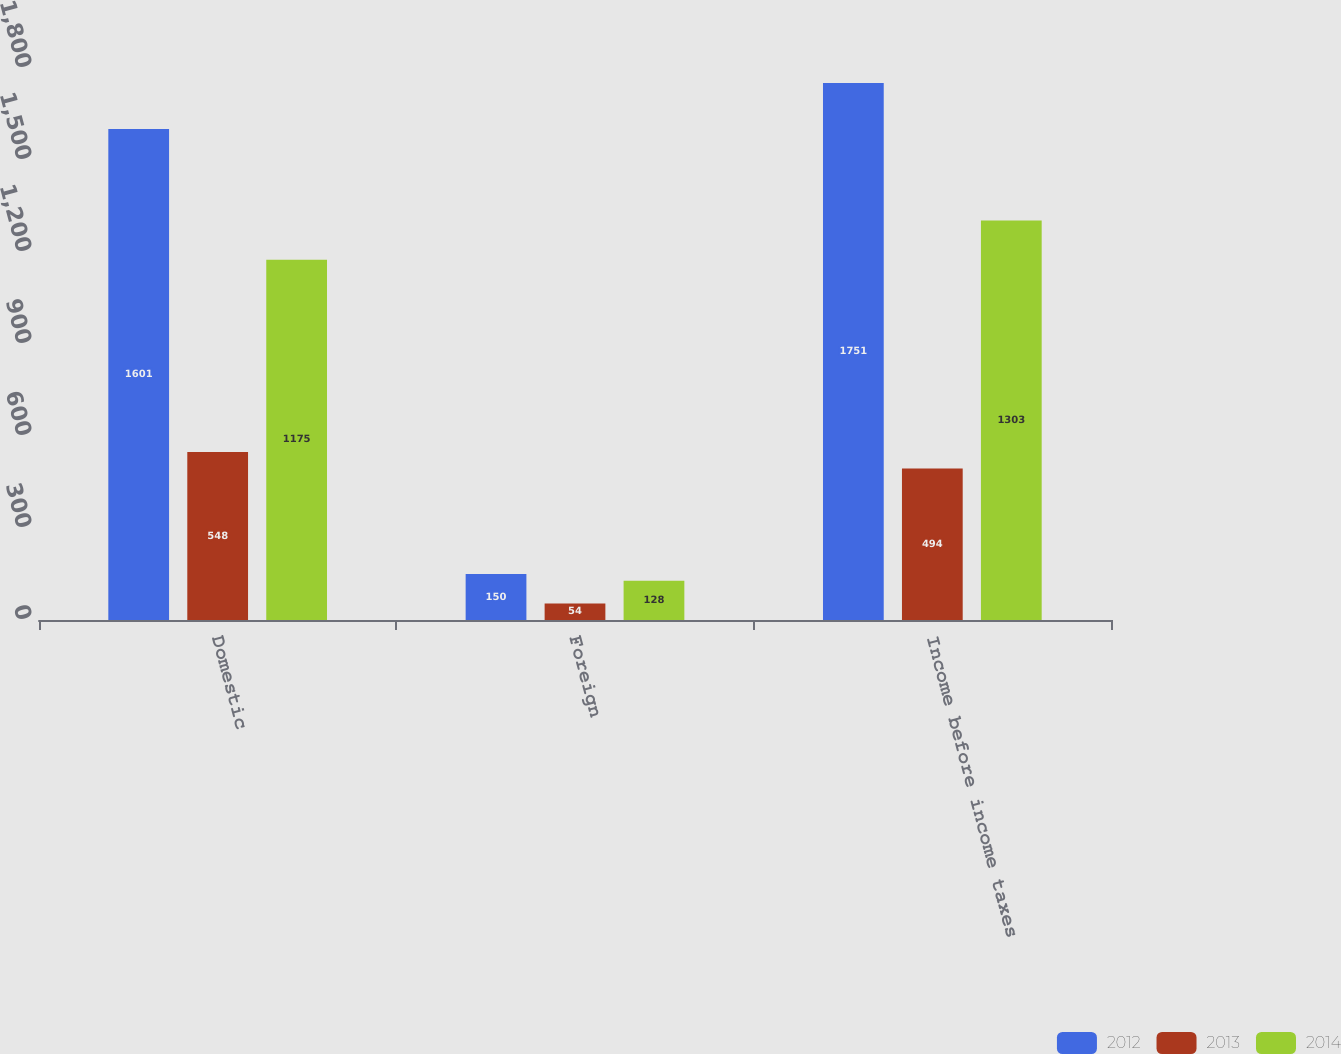Convert chart to OTSL. <chart><loc_0><loc_0><loc_500><loc_500><stacked_bar_chart><ecel><fcel>Domestic<fcel>Foreign<fcel>Income before income taxes<nl><fcel>2012<fcel>1601<fcel>150<fcel>1751<nl><fcel>2013<fcel>548<fcel>54<fcel>494<nl><fcel>2014<fcel>1175<fcel>128<fcel>1303<nl></chart> 